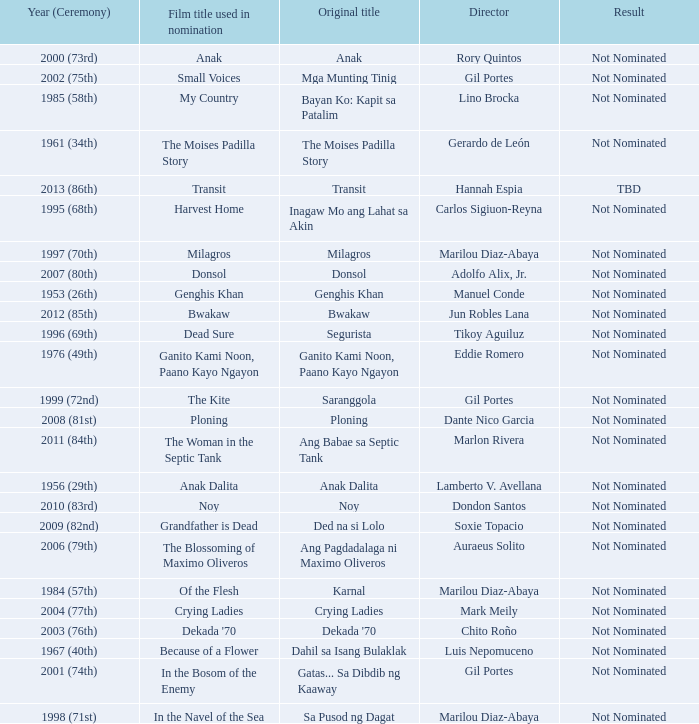Could you parse the entire table as a dict? {'header': ['Year (Ceremony)', 'Film title used in nomination', 'Original title', 'Director', 'Result'], 'rows': [['2000 (73rd)', 'Anak', 'Anak', 'Rory Quintos', 'Not Nominated'], ['2002 (75th)', 'Small Voices', 'Mga Munting Tinig', 'Gil Portes', 'Not Nominated'], ['1985 (58th)', 'My Country', 'Bayan Ko: Kapit sa Patalim', 'Lino Brocka', 'Not Nominated'], ['1961 (34th)', 'The Moises Padilla Story', 'The Moises Padilla Story', 'Gerardo de León', 'Not Nominated'], ['2013 (86th)', 'Transit', 'Transit', 'Hannah Espia', 'TBD'], ['1995 (68th)', 'Harvest Home', 'Inagaw Mo ang Lahat sa Akin', 'Carlos Sigiuon-Reyna', 'Not Nominated'], ['1997 (70th)', 'Milagros', 'Milagros', 'Marilou Diaz-Abaya', 'Not Nominated'], ['2007 (80th)', 'Donsol', 'Donsol', 'Adolfo Alix, Jr.', 'Not Nominated'], ['1953 (26th)', 'Genghis Khan', 'Genghis Khan', 'Manuel Conde', 'Not Nominated'], ['2012 (85th)', 'Bwakaw', 'Bwakaw', 'Jun Robles Lana', 'Not Nominated'], ['1996 (69th)', 'Dead Sure', 'Segurista', 'Tikoy Aguiluz', 'Not Nominated'], ['1976 (49th)', 'Ganito Kami Noon, Paano Kayo Ngayon', 'Ganito Kami Noon, Paano Kayo Ngayon', 'Eddie Romero', 'Not Nominated'], ['1999 (72nd)', 'The Kite', 'Saranggola', 'Gil Portes', 'Not Nominated'], ['2008 (81st)', 'Ploning', 'Ploning', 'Dante Nico Garcia', 'Not Nominated'], ['2011 (84th)', 'The Woman in the Septic Tank', 'Ang Babae sa Septic Tank', 'Marlon Rivera', 'Not Nominated'], ['1956 (29th)', 'Anak Dalita', 'Anak Dalita', 'Lamberto V. Avellana', 'Not Nominated'], ['2010 (83rd)', 'Noy', 'Noy', 'Dondon Santos', 'Not Nominated'], ['2009 (82nd)', 'Grandfather is Dead', 'Ded na si Lolo', 'Soxie Topacio', 'Not Nominated'], ['2006 (79th)', 'The Blossoming of Maximo Oliveros', 'Ang Pagdadalaga ni Maximo Oliveros', 'Auraeus Solito', 'Not Nominated'], ['1984 (57th)', 'Of the Flesh', 'Karnal', 'Marilou Diaz-Abaya', 'Not Nominated'], ['2004 (77th)', 'Crying Ladies', 'Crying Ladies', 'Mark Meily', 'Not Nominated'], ['2003 (76th)', "Dekada '70", "Dekada '70", 'Chito Roño', 'Not Nominated'], ['1967 (40th)', 'Because of a Flower', 'Dahil sa Isang Bulaklak', 'Luis Nepomuceno', 'Not Nominated'], ['2001 (74th)', 'In the Bosom of the Enemy', 'Gatas... Sa Dibdib ng Kaaway', 'Gil Portes', 'Not Nominated'], ['1998 (71st)', 'In the Navel of the Sea', 'Sa Pusod ng Dagat', 'Marilou Diaz-Abaya', 'Not Nominated']]} Who was the director of Small Voices, a film title used in nomination? Gil Portes. 